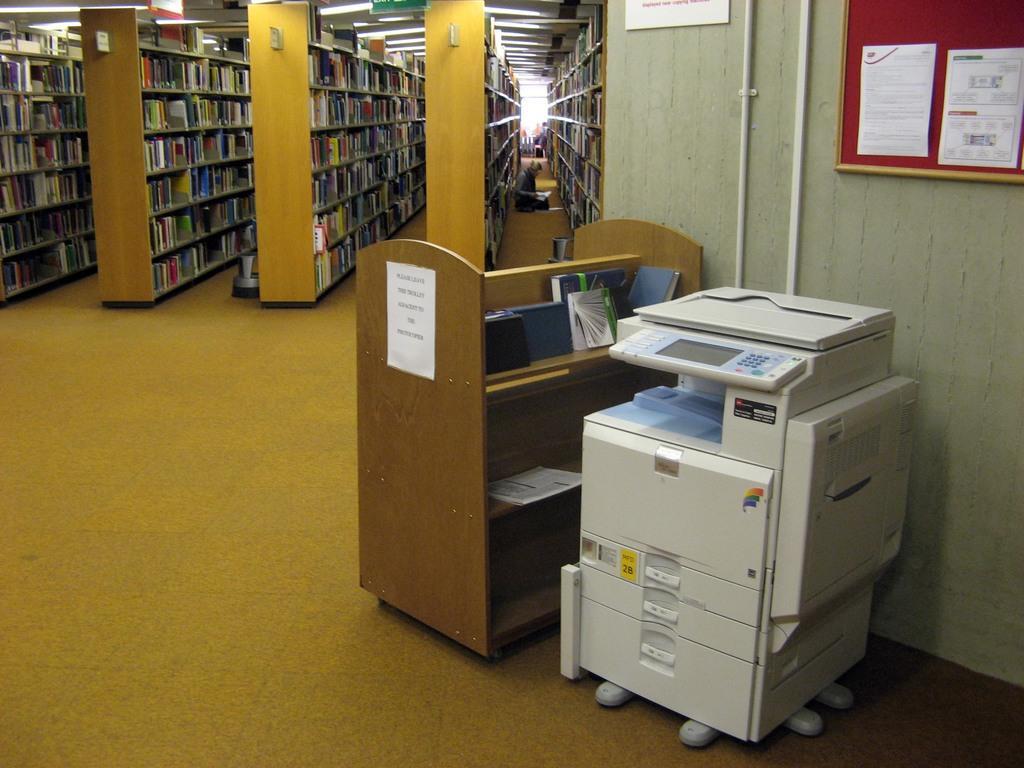How would you summarize this image in a sentence or two? In this image in the center there is a xerox machine and there is a table. On the right side of the wall there is a frame and in the center there are shelves with the books and there is a person sitting on the floor. 